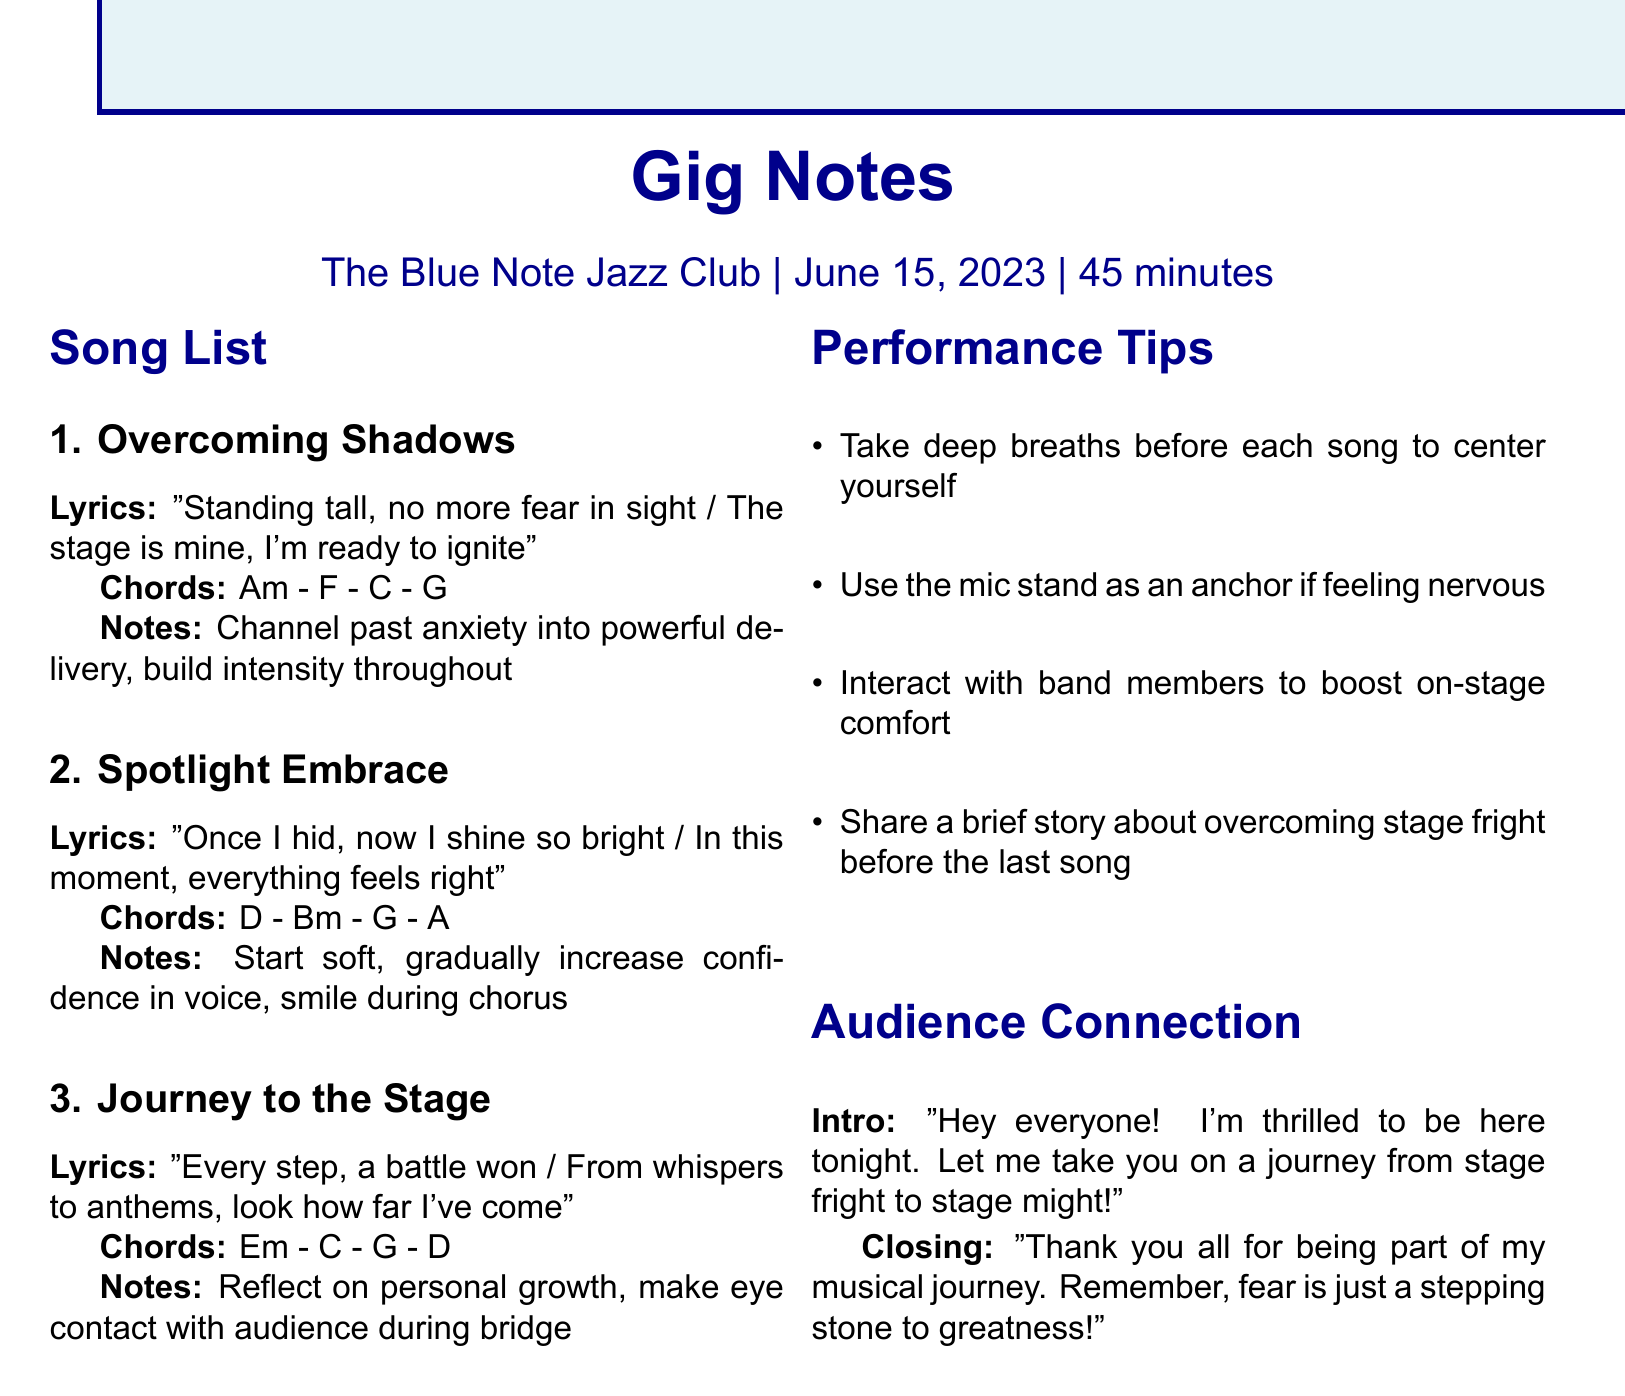What is the venue for the gig? The venue is mentioned at the top of the document.
Answer: The Blue Note Jazz Club What is the date of the gig? The date is specified in the gig details section.
Answer: June 15, 2023 How long is the set duration? The set duration is noted alongside the venue and date.
Answer: 45 minutes What is the chord progression for "Overcoming Shadows"? The chord progression is provided in the song list section for that song.
Answer: Am - F - C - G What emotional delivery is suggested for "Spotlight Embrace"? Emotional notes for that song are outlined in the song list section.
Answer: Start soft, gradually increase confidence in voice, smile during chorus Which performance tip involves breathing? The tips section contains multiple tips, and one specifically mentions breathing.
Answer: Take deep breaths before each song to center yourself What is the closing message to the audience? The closing message is written in the audience connection section of the document.
Answer: Thank you all for being part of my musical journey. Remember, fear is just a stepping stone to greatness! How many songs are listed in total? This can be derived from the song list section of the document.
Answer: 3 What is the intro line for audience connection? The intro line is stated in the audience connection section.
Answer: Hey everyone! I'm thrilled to be here tonight. Let me take you on a journey from stage fright to stage might! What should the performer reflect on during "Journey to the Stage"? Emotional notes for that song are noted in the song list.
Answer: Reflect on personal growth, make eye contact with audience during bridge 